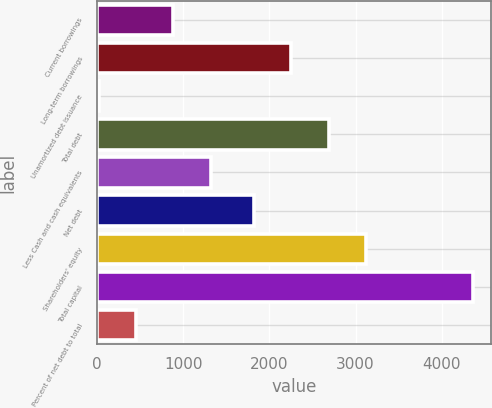Convert chart to OTSL. <chart><loc_0><loc_0><loc_500><loc_500><bar_chart><fcel>Current borrowings<fcel>Long-term borrowings<fcel>Unamortized debt issuance<fcel>Total debt<fcel>Less Cash and cash equivalents<fcel>Net debt<fcel>Shareholders' equity<fcel>Total capital<fcel>Percent of net debt to total<nl><fcel>886.02<fcel>2253.46<fcel>17.7<fcel>2687.62<fcel>1320.18<fcel>1819.3<fcel>3121.78<fcel>4359.3<fcel>451.86<nl></chart> 